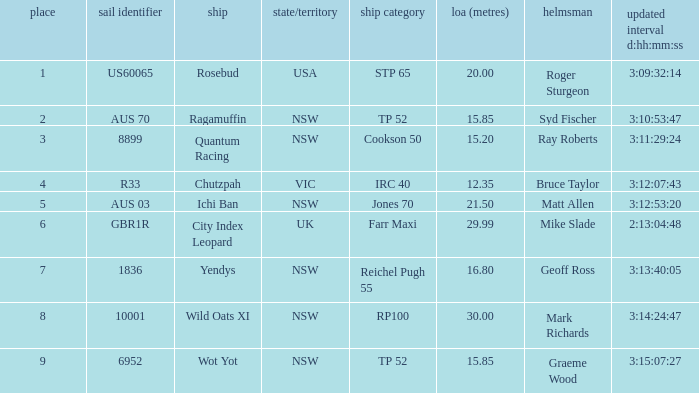What were all Yachts with a sail number of 6952? Wot Yot. 